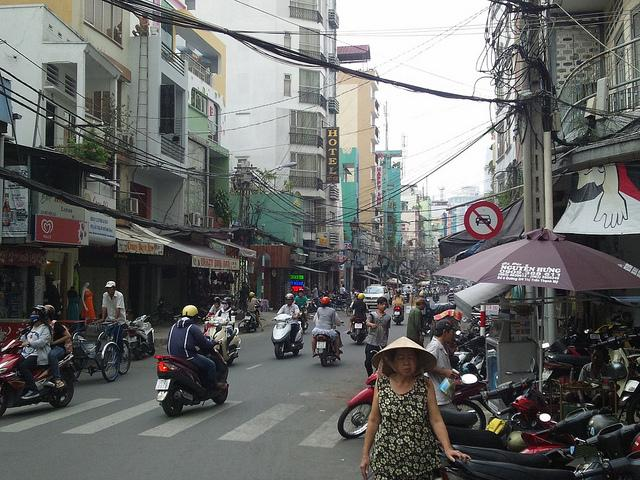Why is the woman wearing a triangular hat?

Choices:
A) dress code
B) visibility
C) protection
D) camouflage protection 